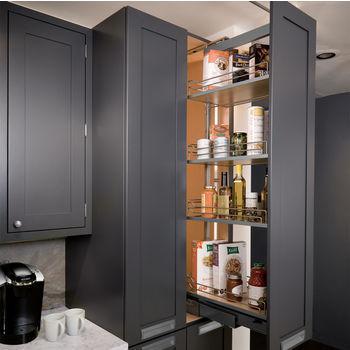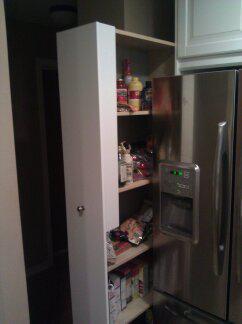The first image is the image on the left, the second image is the image on the right. Examine the images to the left and right. Is the description "Left image shows a vertical storage pantry that pulls out, and the image does not include a refrigerator." accurate? Answer yes or no. Yes. The first image is the image on the left, the second image is the image on the right. Evaluate the accuracy of this statement regarding the images: "At least one set of doors is closed in the image on the right.". Is it true? Answer yes or no. No. 